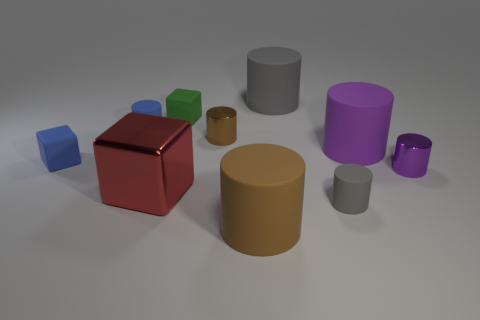What is the shape of the green matte thing on the right side of the tiny blue object in front of the blue matte cylinder?
Your answer should be very brief. Cube. Are there any other things that have the same shape as the tiny gray rubber thing?
Make the answer very short. Yes. What is the color of the other tiny matte thing that is the same shape as the small gray rubber thing?
Ensure brevity in your answer.  Blue. What shape is the shiny thing that is both right of the red shiny thing and to the left of the big brown thing?
Offer a very short reply. Cylinder. Is the number of tiny matte objects less than the number of cylinders?
Your answer should be compact. Yes. Are there any large red objects?
Provide a short and direct response. Yes. How many other things are there of the same size as the purple rubber thing?
Keep it short and to the point. 3. Is the blue cylinder made of the same material as the gray thing behind the tiny gray thing?
Offer a very short reply. Yes. Is the number of big cubes that are behind the tiny green matte cube the same as the number of large things that are in front of the tiny purple object?
Provide a succinct answer. No. What material is the green thing?
Your answer should be very brief. Rubber. 